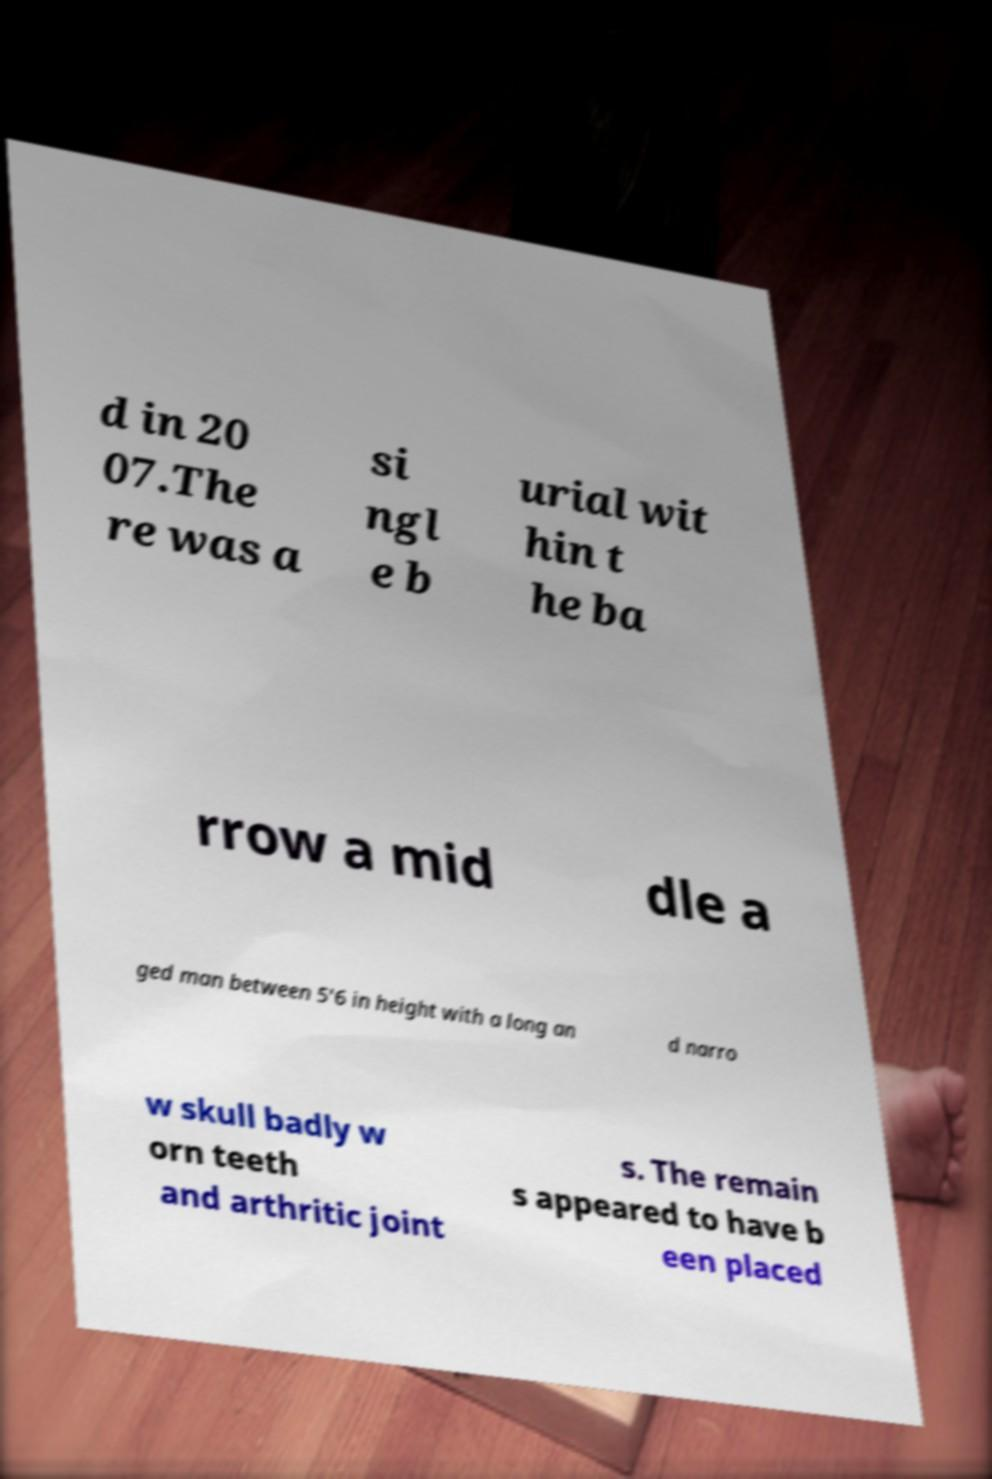What messages or text are displayed in this image? I need them in a readable, typed format. d in 20 07.The re was a si ngl e b urial wit hin t he ba rrow a mid dle a ged man between 5'6 in height with a long an d narro w skull badly w orn teeth and arthritic joint s. The remain s appeared to have b een placed 